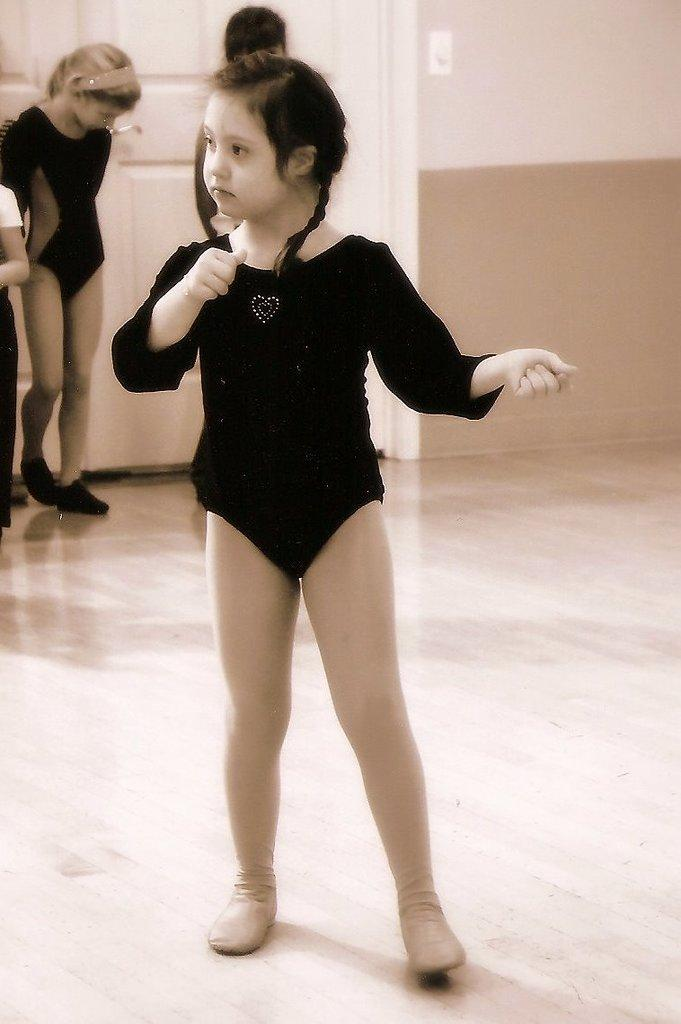Who is the main subject in the image? There is a girl in the image. What is the girl wearing? The girl is wearing a black dress. What is the girl doing in the image? The girl is performing on the floor. How many children are in the background of the image? There are three children in the background of the image. What can be seen on the wall in the background? There are white color doors on the wall in the background. What type of linen is being used to cover the yoke in the image? There is no yoke or linen present in the image. What sound can be heard coming from the girl while she is performing? The image does not provide any information about the sound, as it is a still image. 